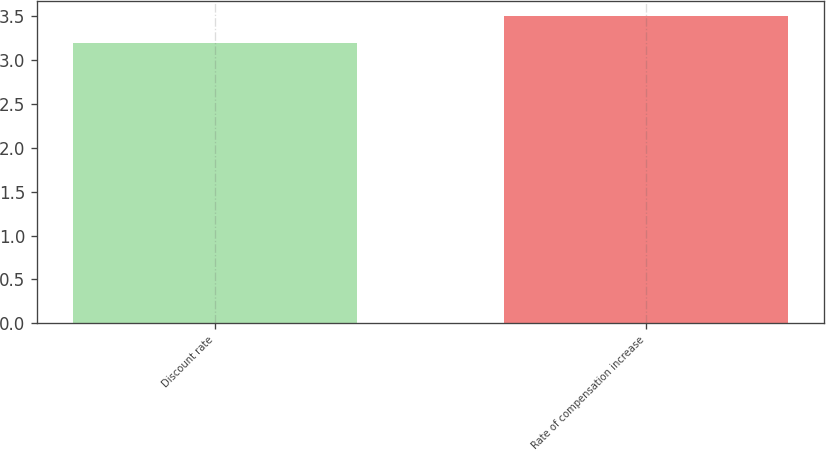Convert chart to OTSL. <chart><loc_0><loc_0><loc_500><loc_500><bar_chart><fcel>Discount rate<fcel>Rate of compensation increase<nl><fcel>3.2<fcel>3.5<nl></chart> 